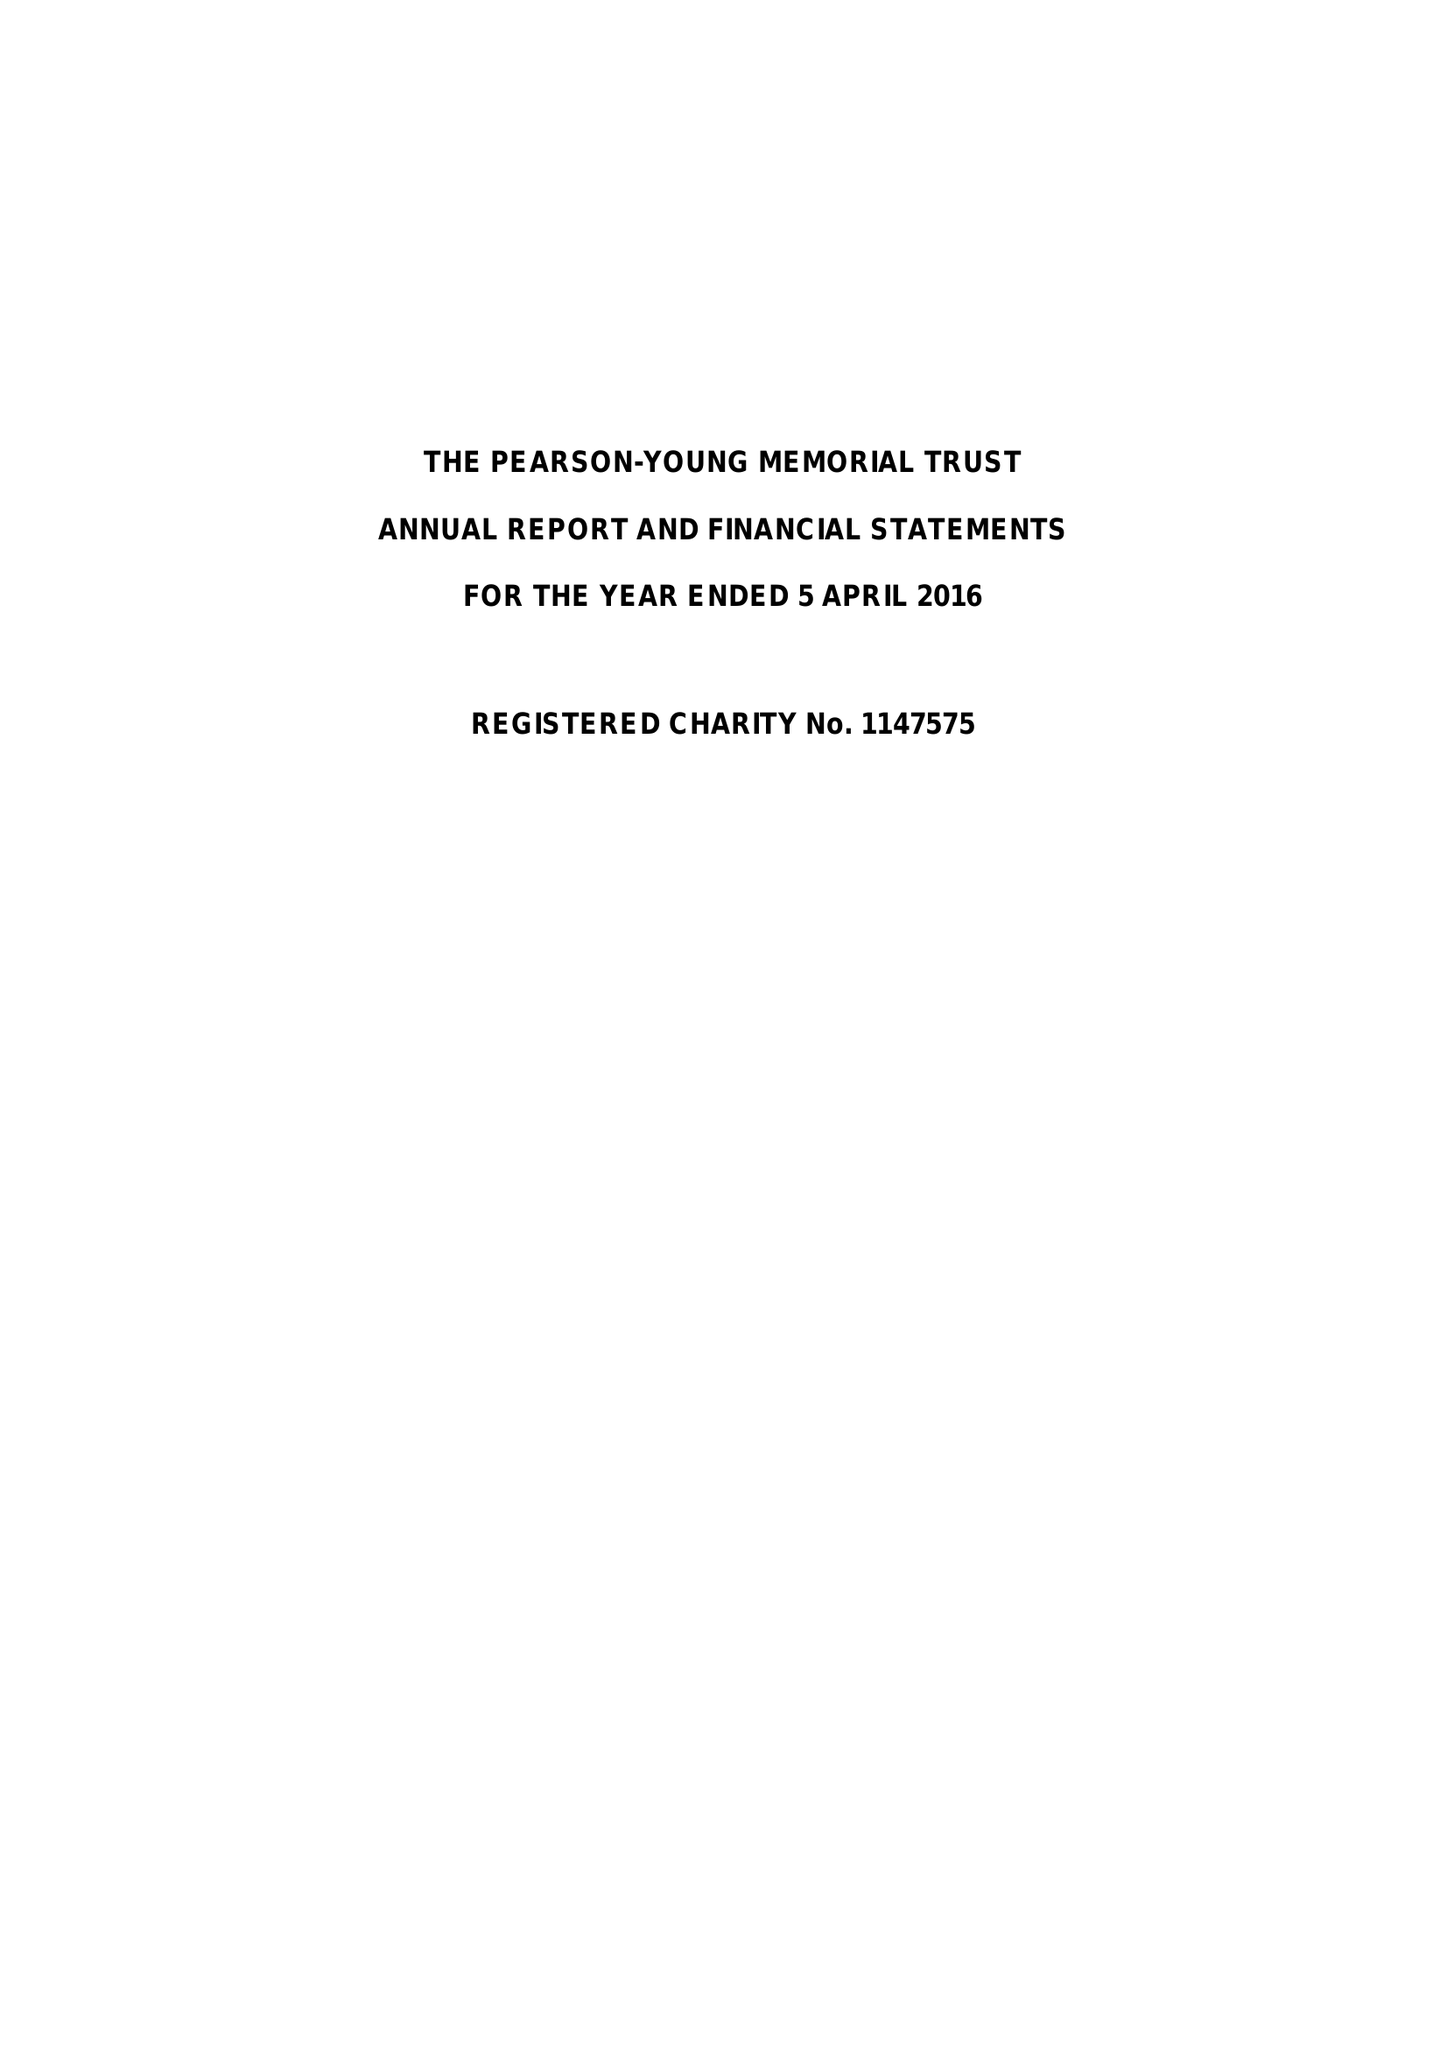What is the value for the charity_name?
Answer the question using a single word or phrase. The Pearson-Young Memorial Trust 